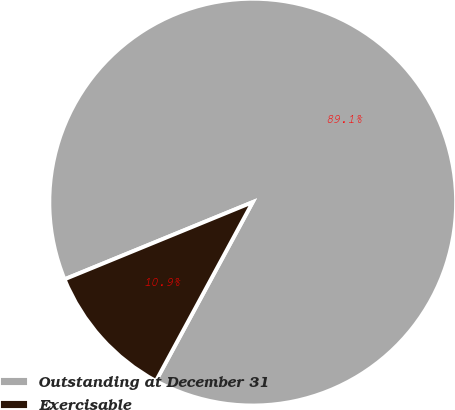<chart> <loc_0><loc_0><loc_500><loc_500><pie_chart><fcel>Outstanding at December 31<fcel>Exercisable<nl><fcel>89.09%<fcel>10.91%<nl></chart> 